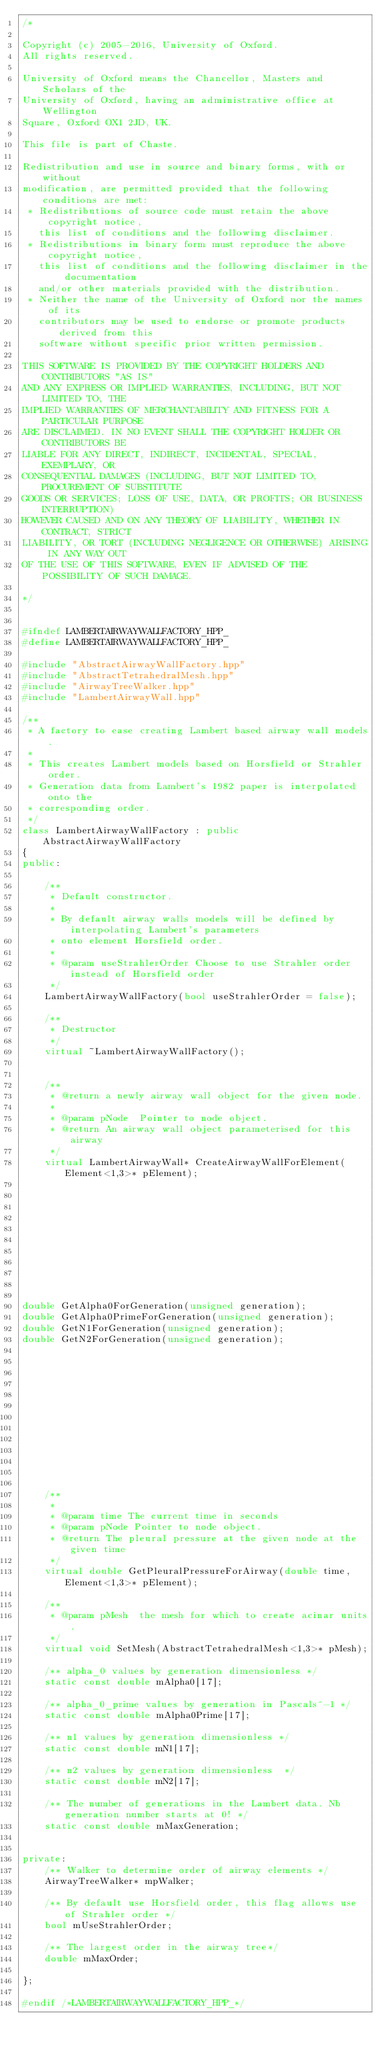Convert code to text. <code><loc_0><loc_0><loc_500><loc_500><_C++_>/*

Copyright (c) 2005-2016, University of Oxford.
All rights reserved.

University of Oxford means the Chancellor, Masters and Scholars of the
University of Oxford, having an administrative office at Wellington
Square, Oxford OX1 2JD, UK.

This file is part of Chaste.

Redistribution and use in source and binary forms, with or without
modification, are permitted provided that the following conditions are met:
 * Redistributions of source code must retain the above copyright notice,
   this list of conditions and the following disclaimer.
 * Redistributions in binary form must reproduce the above copyright notice,
   this list of conditions and the following disclaimer in the documentation
   and/or other materials provided with the distribution.
 * Neither the name of the University of Oxford nor the names of its
   contributors may be used to endorse or promote products derived from this
   software without specific prior written permission.

THIS SOFTWARE IS PROVIDED BY THE COPYRIGHT HOLDERS AND CONTRIBUTORS "AS IS"
AND ANY EXPRESS OR IMPLIED WARRANTIES, INCLUDING, BUT NOT LIMITED TO, THE
IMPLIED WARRANTIES OF MERCHANTABILITY AND FITNESS FOR A PARTICULAR PURPOSE
ARE DISCLAIMED. IN NO EVENT SHALL THE COPYRIGHT HOLDER OR CONTRIBUTORS BE
LIABLE FOR ANY DIRECT, INDIRECT, INCIDENTAL, SPECIAL, EXEMPLARY, OR
CONSEQUENTIAL DAMAGES (INCLUDING, BUT NOT LIMITED TO, PROCUREMENT OF SUBSTITUTE
GOODS OR SERVICES; LOSS OF USE, DATA, OR PROFITS; OR BUSINESS INTERRUPTION)
HOWEVER CAUSED AND ON ANY THEORY OF LIABILITY, WHETHER IN CONTRACT, STRICT
LIABILITY, OR TORT (INCLUDING NEGLIGENCE OR OTHERWISE) ARISING IN ANY WAY OUT
OF THE USE OF THIS SOFTWARE, EVEN IF ADVISED OF THE POSSIBILITY OF SUCH DAMAGE.

*/


#ifndef LAMBERTAIRWAYWALLFACTORY_HPP_
#define LAMBERTAIRWAYWALLFACTORY_HPP_

#include "AbstractAirwayWallFactory.hpp"
#include "AbstractTetrahedralMesh.hpp"
#include "AirwayTreeWalker.hpp"
#include "LambertAirwayWall.hpp"

/**
 * A factory to ease creating Lambert based airway wall models.
 *
 * This creates Lambert models based on Horsfield or Strahler order.
 * Generation data from Lambert's 1982 paper is interpolated onto the
 * corresponding order.
 */
class LambertAirwayWallFactory : public AbstractAirwayWallFactory
{
public:

    /**
     * Default constructor.
     *
     * By default airway walls models will be defined by interpolating Lambert's parameters
     * onto element Horsfield order.
     *
     * @param useStrahlerOrder Choose to use Strahler order instead of Horsfield order
     */
    LambertAirwayWallFactory(bool useStrahlerOrder = false);

    /**
     * Destructor
     */
    virtual ~LambertAirwayWallFactory();


    /**
     * @return a newly airway wall object for the given node.
     *
     * @param pNode  Pointer to node object.
     * @return An airway wall object parameterised for this airway
     */
    virtual LambertAirwayWall* CreateAirwayWallForElement(Element<1,3>* pElement);
  
  
  
  
  
  
  
  
  
  
  
double GetAlpha0ForGeneration(unsigned generation);
double GetAlpha0PrimeForGeneration(unsigned generation);  
double GetN1ForGeneration(unsigned generation);
double GetN2ForGeneration(unsigned generation);













    /**
     *
     * @param time The current time in seconds
     * @param pNode Pointer to node object.
     * @return The pleural pressure at the given node at the given time
     */
    virtual double GetPleuralPressureForAirway(double time, Element<1,3>* pElement);

    /**
     * @param pMesh  the mesh for which to create acinar units.
     */
    virtual void SetMesh(AbstractTetrahedralMesh<1,3>* pMesh);
    
    /** alpha_0 values by generation dimensionless */
    static const double mAlpha0[17];

    /** alpha_0_prime values by generation in Pascals^-1 */
    static const double mAlpha0Prime[17];

    /** n1 values by generation dimensionless */
    static const double mN1[17];

    /** n2 values by generation dimensionless  */
    static const double mN2[17];

    /** The number of generations in the Lambert data. Nb generation number starts at 0! */
    static const double mMaxGeneration;


private:
    /** Walker to determine order of airway elements */
    AirwayTreeWalker* mpWalker;

    /** By default use Horsfield order, this flag allows use of Strahler order */
    bool mUseStrahlerOrder;

    /** The largest order in the airway tree*/
    double mMaxOrder;

};

#endif /*LAMBERTAIRWAYWALLFACTORY_HPP_*/

</code> 